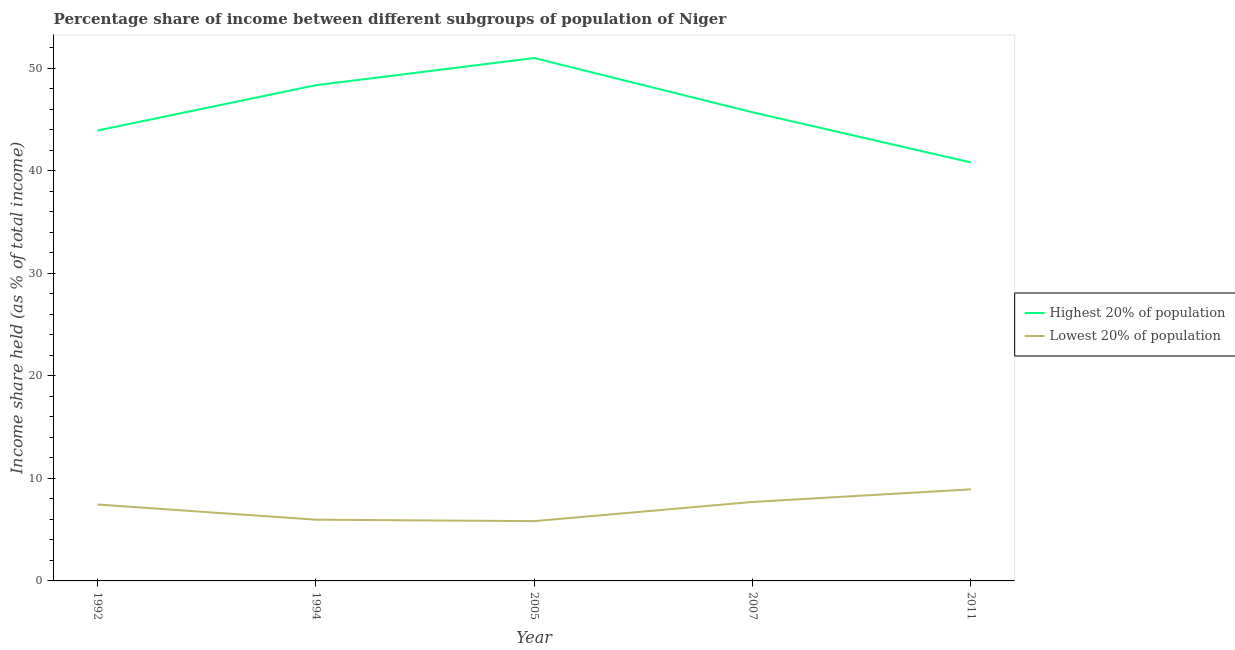How many different coloured lines are there?
Keep it short and to the point. 2. Does the line corresponding to income share held by lowest 20% of the population intersect with the line corresponding to income share held by highest 20% of the population?
Your response must be concise. No. Is the number of lines equal to the number of legend labels?
Provide a succinct answer. Yes. What is the income share held by lowest 20% of the population in 2005?
Offer a very short reply. 5.83. Across all years, what is the maximum income share held by highest 20% of the population?
Your answer should be compact. 50.98. Across all years, what is the minimum income share held by lowest 20% of the population?
Your answer should be very brief. 5.83. In which year was the income share held by highest 20% of the population maximum?
Your answer should be compact. 2005. What is the total income share held by highest 20% of the population in the graph?
Provide a short and direct response. 229.71. What is the difference between the income share held by lowest 20% of the population in 1994 and that in 2005?
Your answer should be compact. 0.14. What is the difference between the income share held by highest 20% of the population in 1992 and the income share held by lowest 20% of the population in 2007?
Your answer should be compact. 36.21. What is the average income share held by highest 20% of the population per year?
Provide a short and direct response. 45.94. In the year 2011, what is the difference between the income share held by lowest 20% of the population and income share held by highest 20% of the population?
Provide a succinct answer. -31.87. In how many years, is the income share held by lowest 20% of the population greater than 36 %?
Make the answer very short. 0. What is the ratio of the income share held by highest 20% of the population in 1992 to that in 2007?
Provide a short and direct response. 0.96. What is the difference between the highest and the second highest income share held by highest 20% of the population?
Make the answer very short. 2.65. What is the difference between the highest and the lowest income share held by lowest 20% of the population?
Offer a terse response. 3.1. In how many years, is the income share held by lowest 20% of the population greater than the average income share held by lowest 20% of the population taken over all years?
Make the answer very short. 3. Does the income share held by highest 20% of the population monotonically increase over the years?
Offer a terse response. No. Is the income share held by lowest 20% of the population strictly less than the income share held by highest 20% of the population over the years?
Keep it short and to the point. Yes. How many lines are there?
Ensure brevity in your answer.  2. What is the difference between two consecutive major ticks on the Y-axis?
Provide a succinct answer. 10. Are the values on the major ticks of Y-axis written in scientific E-notation?
Offer a very short reply. No. Does the graph contain grids?
Provide a succinct answer. No. How many legend labels are there?
Offer a terse response. 2. How are the legend labels stacked?
Offer a very short reply. Vertical. What is the title of the graph?
Give a very brief answer. Percentage share of income between different subgroups of population of Niger. Does "Primary" appear as one of the legend labels in the graph?
Offer a very short reply. No. What is the label or title of the Y-axis?
Give a very brief answer. Income share held (as % of total income). What is the Income share held (as % of total income) of Highest 20% of population in 1992?
Provide a short and direct response. 43.91. What is the Income share held (as % of total income) of Lowest 20% of population in 1992?
Keep it short and to the point. 7.45. What is the Income share held (as % of total income) in Highest 20% of population in 1994?
Keep it short and to the point. 48.33. What is the Income share held (as % of total income) in Lowest 20% of population in 1994?
Offer a terse response. 5.97. What is the Income share held (as % of total income) of Highest 20% of population in 2005?
Offer a terse response. 50.98. What is the Income share held (as % of total income) in Lowest 20% of population in 2005?
Your answer should be very brief. 5.83. What is the Income share held (as % of total income) of Highest 20% of population in 2007?
Give a very brief answer. 45.69. What is the Income share held (as % of total income) in Lowest 20% of population in 2007?
Offer a very short reply. 7.7. What is the Income share held (as % of total income) of Highest 20% of population in 2011?
Your answer should be compact. 40.8. What is the Income share held (as % of total income) of Lowest 20% of population in 2011?
Provide a short and direct response. 8.93. Across all years, what is the maximum Income share held (as % of total income) of Highest 20% of population?
Offer a very short reply. 50.98. Across all years, what is the maximum Income share held (as % of total income) of Lowest 20% of population?
Keep it short and to the point. 8.93. Across all years, what is the minimum Income share held (as % of total income) of Highest 20% of population?
Keep it short and to the point. 40.8. Across all years, what is the minimum Income share held (as % of total income) in Lowest 20% of population?
Give a very brief answer. 5.83. What is the total Income share held (as % of total income) in Highest 20% of population in the graph?
Offer a terse response. 229.71. What is the total Income share held (as % of total income) in Lowest 20% of population in the graph?
Offer a terse response. 35.88. What is the difference between the Income share held (as % of total income) in Highest 20% of population in 1992 and that in 1994?
Provide a short and direct response. -4.42. What is the difference between the Income share held (as % of total income) in Lowest 20% of population in 1992 and that in 1994?
Your answer should be compact. 1.48. What is the difference between the Income share held (as % of total income) of Highest 20% of population in 1992 and that in 2005?
Offer a very short reply. -7.07. What is the difference between the Income share held (as % of total income) of Lowest 20% of population in 1992 and that in 2005?
Offer a very short reply. 1.62. What is the difference between the Income share held (as % of total income) in Highest 20% of population in 1992 and that in 2007?
Provide a succinct answer. -1.78. What is the difference between the Income share held (as % of total income) in Highest 20% of population in 1992 and that in 2011?
Keep it short and to the point. 3.11. What is the difference between the Income share held (as % of total income) of Lowest 20% of population in 1992 and that in 2011?
Your response must be concise. -1.48. What is the difference between the Income share held (as % of total income) in Highest 20% of population in 1994 and that in 2005?
Your response must be concise. -2.65. What is the difference between the Income share held (as % of total income) of Lowest 20% of population in 1994 and that in 2005?
Offer a terse response. 0.14. What is the difference between the Income share held (as % of total income) in Highest 20% of population in 1994 and that in 2007?
Make the answer very short. 2.64. What is the difference between the Income share held (as % of total income) of Lowest 20% of population in 1994 and that in 2007?
Ensure brevity in your answer.  -1.73. What is the difference between the Income share held (as % of total income) in Highest 20% of population in 1994 and that in 2011?
Keep it short and to the point. 7.53. What is the difference between the Income share held (as % of total income) in Lowest 20% of population in 1994 and that in 2011?
Give a very brief answer. -2.96. What is the difference between the Income share held (as % of total income) in Highest 20% of population in 2005 and that in 2007?
Give a very brief answer. 5.29. What is the difference between the Income share held (as % of total income) of Lowest 20% of population in 2005 and that in 2007?
Provide a succinct answer. -1.87. What is the difference between the Income share held (as % of total income) of Highest 20% of population in 2005 and that in 2011?
Provide a succinct answer. 10.18. What is the difference between the Income share held (as % of total income) of Lowest 20% of population in 2005 and that in 2011?
Provide a succinct answer. -3.1. What is the difference between the Income share held (as % of total income) of Highest 20% of population in 2007 and that in 2011?
Your answer should be compact. 4.89. What is the difference between the Income share held (as % of total income) of Lowest 20% of population in 2007 and that in 2011?
Provide a succinct answer. -1.23. What is the difference between the Income share held (as % of total income) of Highest 20% of population in 1992 and the Income share held (as % of total income) of Lowest 20% of population in 1994?
Offer a terse response. 37.94. What is the difference between the Income share held (as % of total income) in Highest 20% of population in 1992 and the Income share held (as % of total income) in Lowest 20% of population in 2005?
Make the answer very short. 38.08. What is the difference between the Income share held (as % of total income) in Highest 20% of population in 1992 and the Income share held (as % of total income) in Lowest 20% of population in 2007?
Ensure brevity in your answer.  36.21. What is the difference between the Income share held (as % of total income) of Highest 20% of population in 1992 and the Income share held (as % of total income) of Lowest 20% of population in 2011?
Your answer should be compact. 34.98. What is the difference between the Income share held (as % of total income) of Highest 20% of population in 1994 and the Income share held (as % of total income) of Lowest 20% of population in 2005?
Offer a terse response. 42.5. What is the difference between the Income share held (as % of total income) in Highest 20% of population in 1994 and the Income share held (as % of total income) in Lowest 20% of population in 2007?
Offer a very short reply. 40.63. What is the difference between the Income share held (as % of total income) of Highest 20% of population in 1994 and the Income share held (as % of total income) of Lowest 20% of population in 2011?
Make the answer very short. 39.4. What is the difference between the Income share held (as % of total income) of Highest 20% of population in 2005 and the Income share held (as % of total income) of Lowest 20% of population in 2007?
Your answer should be very brief. 43.28. What is the difference between the Income share held (as % of total income) of Highest 20% of population in 2005 and the Income share held (as % of total income) of Lowest 20% of population in 2011?
Make the answer very short. 42.05. What is the difference between the Income share held (as % of total income) of Highest 20% of population in 2007 and the Income share held (as % of total income) of Lowest 20% of population in 2011?
Your answer should be very brief. 36.76. What is the average Income share held (as % of total income) of Highest 20% of population per year?
Provide a short and direct response. 45.94. What is the average Income share held (as % of total income) of Lowest 20% of population per year?
Your answer should be compact. 7.18. In the year 1992, what is the difference between the Income share held (as % of total income) in Highest 20% of population and Income share held (as % of total income) in Lowest 20% of population?
Keep it short and to the point. 36.46. In the year 1994, what is the difference between the Income share held (as % of total income) of Highest 20% of population and Income share held (as % of total income) of Lowest 20% of population?
Provide a short and direct response. 42.36. In the year 2005, what is the difference between the Income share held (as % of total income) of Highest 20% of population and Income share held (as % of total income) of Lowest 20% of population?
Offer a terse response. 45.15. In the year 2007, what is the difference between the Income share held (as % of total income) in Highest 20% of population and Income share held (as % of total income) in Lowest 20% of population?
Make the answer very short. 37.99. In the year 2011, what is the difference between the Income share held (as % of total income) in Highest 20% of population and Income share held (as % of total income) in Lowest 20% of population?
Your answer should be compact. 31.87. What is the ratio of the Income share held (as % of total income) of Highest 20% of population in 1992 to that in 1994?
Make the answer very short. 0.91. What is the ratio of the Income share held (as % of total income) of Lowest 20% of population in 1992 to that in 1994?
Offer a terse response. 1.25. What is the ratio of the Income share held (as % of total income) in Highest 20% of population in 1992 to that in 2005?
Provide a short and direct response. 0.86. What is the ratio of the Income share held (as % of total income) of Lowest 20% of population in 1992 to that in 2005?
Ensure brevity in your answer.  1.28. What is the ratio of the Income share held (as % of total income) in Highest 20% of population in 1992 to that in 2007?
Make the answer very short. 0.96. What is the ratio of the Income share held (as % of total income) of Lowest 20% of population in 1992 to that in 2007?
Offer a very short reply. 0.97. What is the ratio of the Income share held (as % of total income) of Highest 20% of population in 1992 to that in 2011?
Provide a succinct answer. 1.08. What is the ratio of the Income share held (as % of total income) of Lowest 20% of population in 1992 to that in 2011?
Your response must be concise. 0.83. What is the ratio of the Income share held (as % of total income) in Highest 20% of population in 1994 to that in 2005?
Your answer should be very brief. 0.95. What is the ratio of the Income share held (as % of total income) of Lowest 20% of population in 1994 to that in 2005?
Offer a very short reply. 1.02. What is the ratio of the Income share held (as % of total income) of Highest 20% of population in 1994 to that in 2007?
Make the answer very short. 1.06. What is the ratio of the Income share held (as % of total income) of Lowest 20% of population in 1994 to that in 2007?
Make the answer very short. 0.78. What is the ratio of the Income share held (as % of total income) of Highest 20% of population in 1994 to that in 2011?
Keep it short and to the point. 1.18. What is the ratio of the Income share held (as % of total income) in Lowest 20% of population in 1994 to that in 2011?
Your response must be concise. 0.67. What is the ratio of the Income share held (as % of total income) in Highest 20% of population in 2005 to that in 2007?
Ensure brevity in your answer.  1.12. What is the ratio of the Income share held (as % of total income) in Lowest 20% of population in 2005 to that in 2007?
Your answer should be compact. 0.76. What is the ratio of the Income share held (as % of total income) of Highest 20% of population in 2005 to that in 2011?
Provide a succinct answer. 1.25. What is the ratio of the Income share held (as % of total income) in Lowest 20% of population in 2005 to that in 2011?
Your answer should be very brief. 0.65. What is the ratio of the Income share held (as % of total income) of Highest 20% of population in 2007 to that in 2011?
Keep it short and to the point. 1.12. What is the ratio of the Income share held (as % of total income) of Lowest 20% of population in 2007 to that in 2011?
Offer a terse response. 0.86. What is the difference between the highest and the second highest Income share held (as % of total income) of Highest 20% of population?
Provide a succinct answer. 2.65. What is the difference between the highest and the second highest Income share held (as % of total income) of Lowest 20% of population?
Provide a succinct answer. 1.23. What is the difference between the highest and the lowest Income share held (as % of total income) in Highest 20% of population?
Your response must be concise. 10.18. What is the difference between the highest and the lowest Income share held (as % of total income) in Lowest 20% of population?
Offer a very short reply. 3.1. 